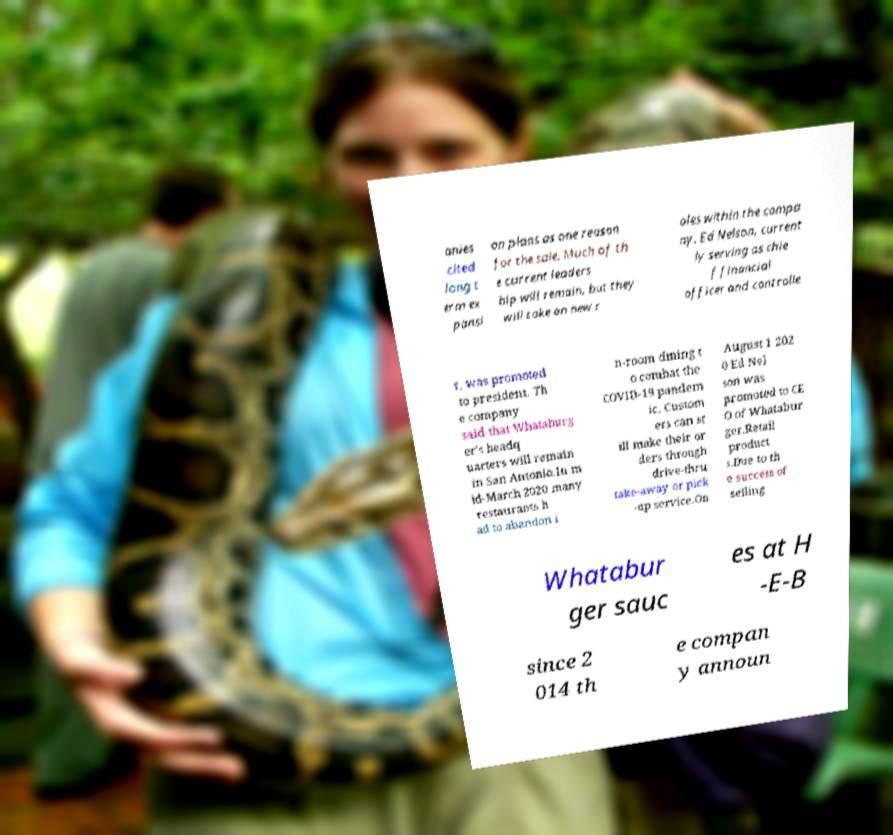Please identify and transcribe the text found in this image. anies cited long t erm ex pansi on plans as one reason for the sale. Much of th e current leaders hip will remain, but they will take on new r oles within the compa ny. Ed Nelson, current ly serving as chie f financial officer and controlle r, was promoted to president. Th e company said that Whataburg er's headq uarters will remain in San Antonio.In m id-March 2020 many restaurants h ad to abandon i n-room dining t o combat the COVID-19 pandem ic. Custom ers can st ill make their or ders through drive-thru take-away or pick -up service.On August 1 202 0 Ed Nel son was promoted to CE O of Whatabur ger.Retail product s.Due to th e success of selling Whatabur ger sauc es at H -E-B since 2 014 th e compan y announ 